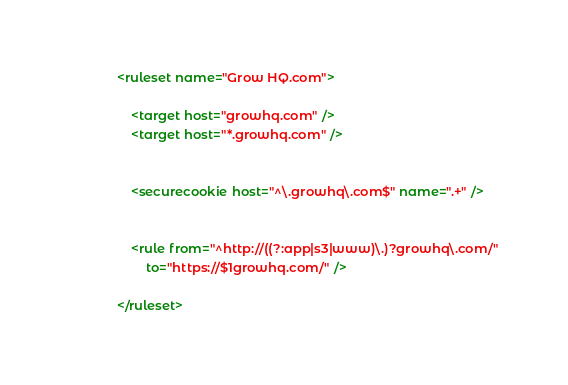<code> <loc_0><loc_0><loc_500><loc_500><_XML_><ruleset name="Grow HQ.com">

	<target host="growhq.com" />
	<target host="*.growhq.com" />


	<securecookie host="^\.growhq\.com$" name=".+" />


	<rule from="^http://((?:app|s3|www)\.)?growhq\.com/"
		to="https://$1growhq.com/" />

</ruleset>
</code> 